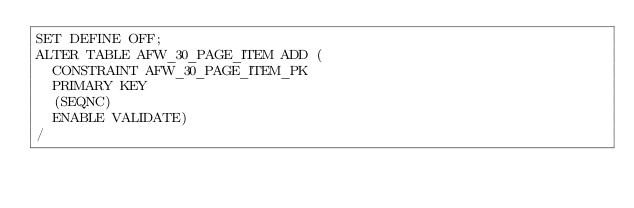<code> <loc_0><loc_0><loc_500><loc_500><_SQL_>SET DEFINE OFF;
ALTER TABLE AFW_30_PAGE_ITEM ADD (
  CONSTRAINT AFW_30_PAGE_ITEM_PK
  PRIMARY KEY
  (SEQNC)
  ENABLE VALIDATE)
/
</code> 